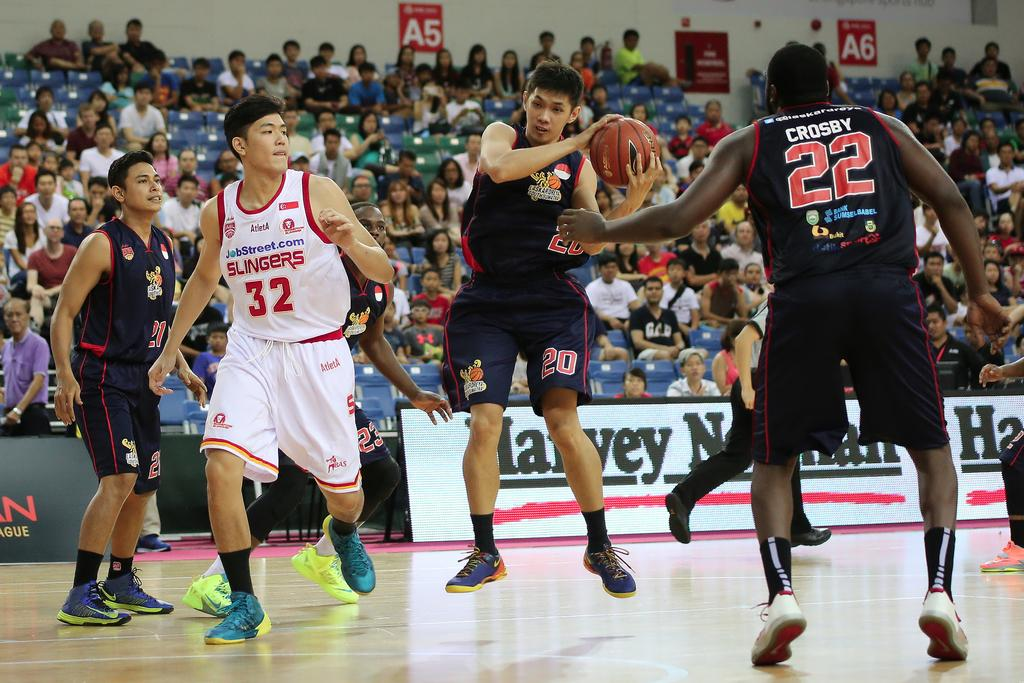Provide a one-sentence caption for the provided image. Player number 22 tries to assist the player with the basketball. 